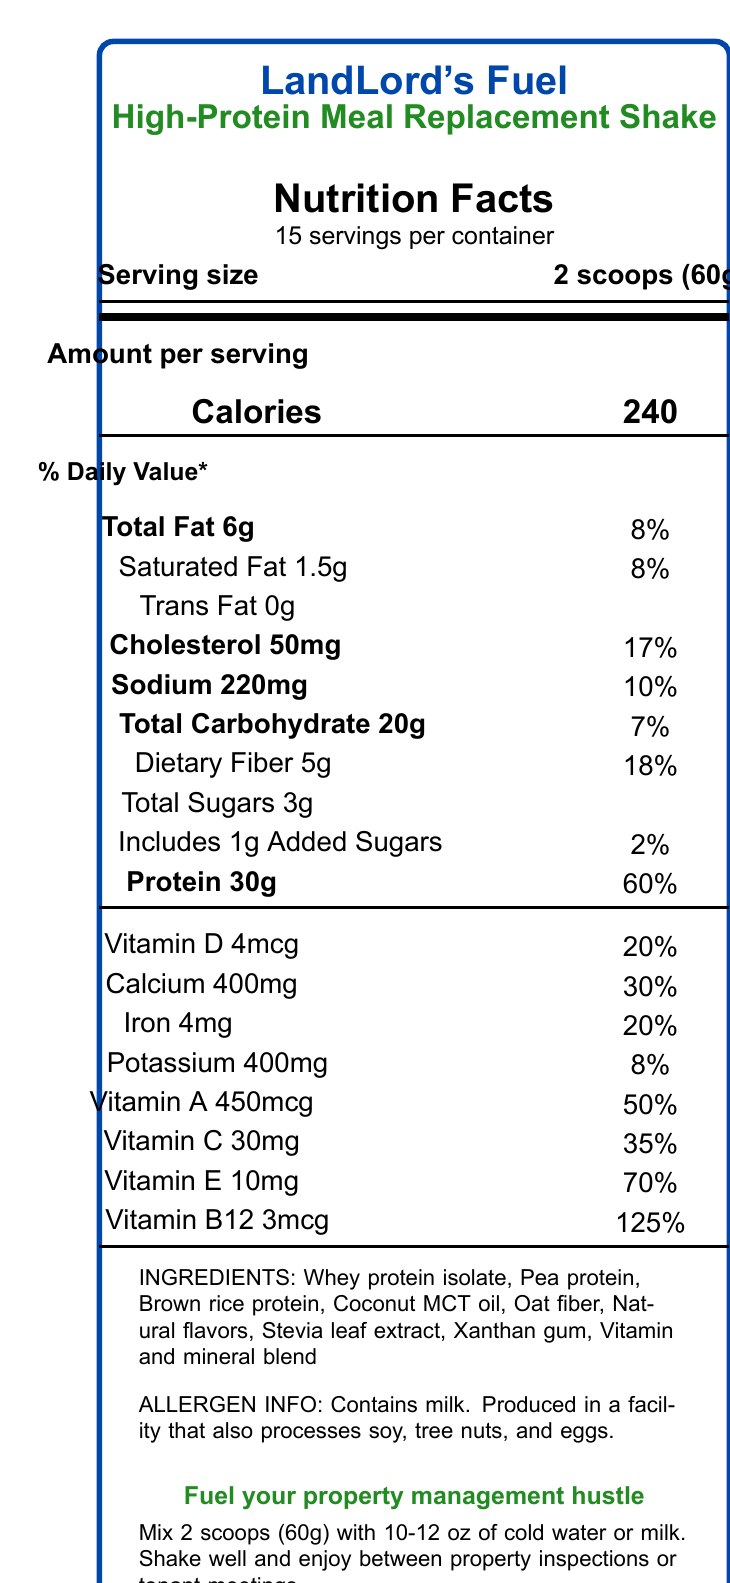What is the serving size? The serving size is specified as "2 scoops (60g)" in the document.
Answer: 2 scoops (60g) How many servings are there per container? The document lists "15 servings per container".
Answer: 15 How many grams of protein are in each serving? The Nutrition Facts section states that one serving contains 30g of protein.
Answer: 30g What percentage of the daily value for Vitamin D does one serving provide? The document shows that one serving provides 20% of the daily value for Vitamin D.
Answer: 20% Does the shake contain any added sugars? The document indicates that each serving "Includes 1g Added Sugars".
Answer: Yes What type of extract is used as a sweetener in the shake? The ingredients list includes "Stevia leaf extract".
Answer: Stevia leaf extract Which statement is NOT a claim made by this product?
A. Supports bone health
B. No artificial ingredients
C. High in protein
D. Good source of fiber The claim statements are "High in protein", "Good source of fiber", "No artificial sweeteners", "Supports bone health". "No artificial ingredients" is not listed.
Answer: B What is the main function of the shake according to the marketing taglines? 
I. To fuel property management hustle
II. To boost athletic performance
III. To provide quick nutrition for busy landlords
IV. To help with weight loss The taglines "Fuel your property management hustle" and "Quick nutrition for busy landlords" suggest these functions.
Answer: I and III Is the shake produced in a facility that handles peanuts? The allergen info states it's produced in a facility that processes soy, tree nuts, and eggs, but peanuts are not mentioned.
Answer: No What is the main idea of the document? The document details nutritional values, ingredient list, preparation instructions, and marketing claims highlighting its benefits for busy professionals.
Answer: The main idea of the document is to provide nutritional information for LandLord's Fuel, a high-protein meal replacement shake designed for busy landlords and property managers. How much Total Fat is in each serving? The document lists Total Fat as 6g per serving.
Answer: 6g What percentage of the daily value is provided by the Iron content in one serving? The document specifies that the Iron content provides 20% of the daily value.
Answer: 20% What are the first three ingredients listed in the shake? The first three ingredients listed are "Whey protein isolate", "Pea protein", and "Brown rice protein".
Answer: Whey protein isolate, Pea protein, Brown rice protein How should you prepare the shake for consumption? The preparation instructions state to mix 2 scoops (60g) with 10-12 oz of cold water or milk, shake well, and consume between property duties.
Answer: Mix 2 scoops (60g) with 10-12 oz of cold water or milk. Shake well and enjoy between property inspections or tenant meetings. What is the calorie count per serving? The document specifies that each serving contains 240 calories.
Answer: 240 Is it mentioned how many grams of trans fat are in each serving? The document states that each serving contains 0g of trans fat.
Answer: Yes Is there a mention of whether the product is organic? The document does not provide any information regarding whether the product is organic or not.
Answer: Cannot be determined 